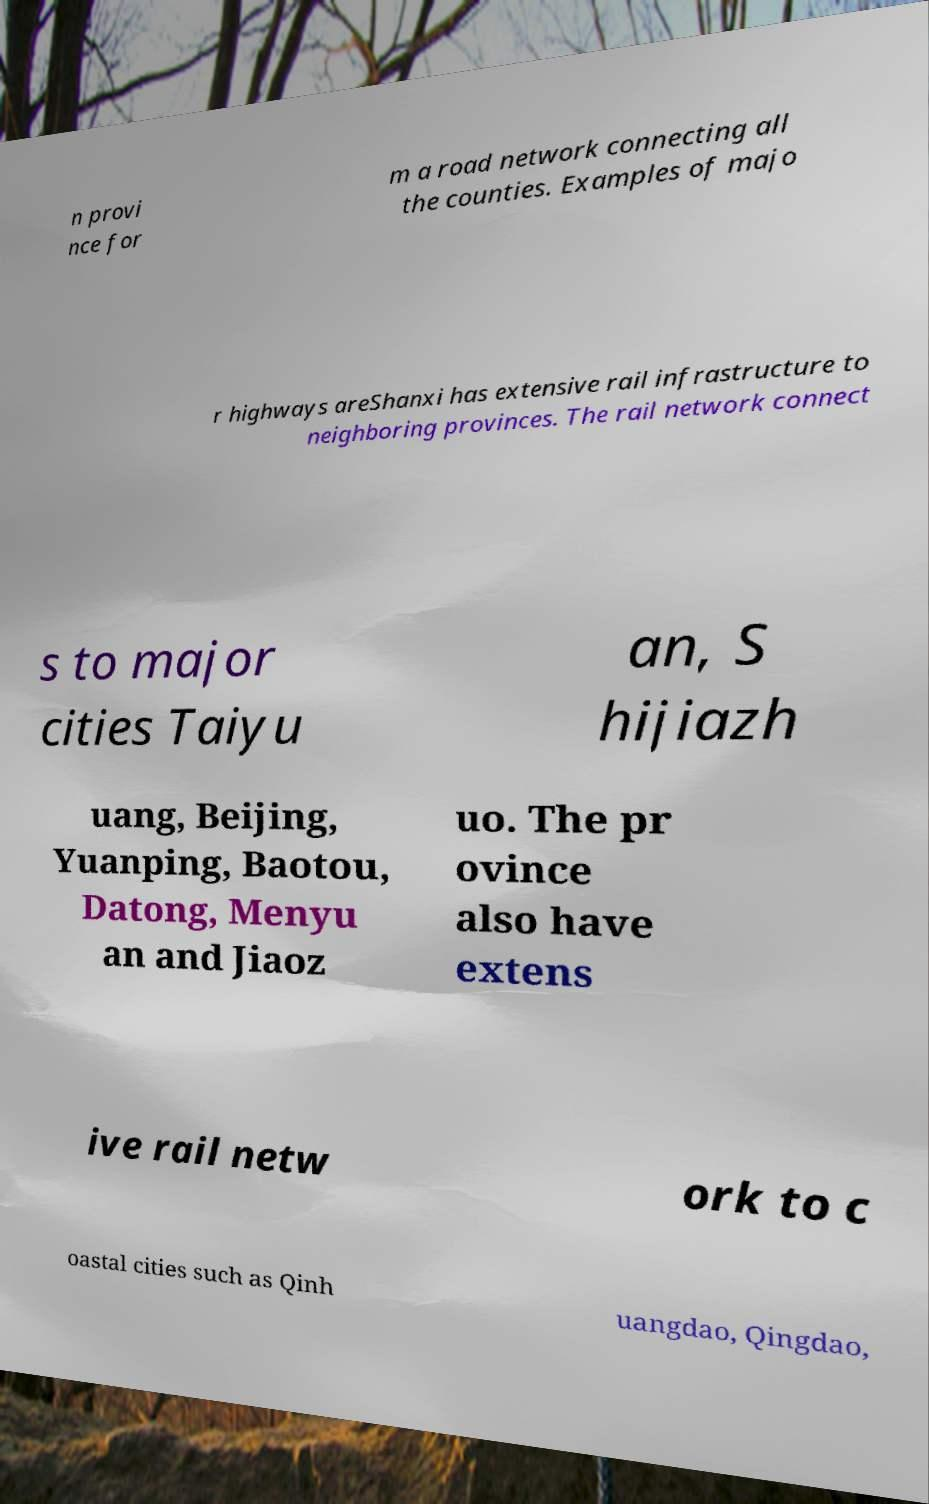For documentation purposes, I need the text within this image transcribed. Could you provide that? n provi nce for m a road network connecting all the counties. Examples of majo r highways areShanxi has extensive rail infrastructure to neighboring provinces. The rail network connect s to major cities Taiyu an, S hijiazh uang, Beijing, Yuanping, Baotou, Datong, Menyu an and Jiaoz uo. The pr ovince also have extens ive rail netw ork to c oastal cities such as Qinh uangdao, Qingdao, 